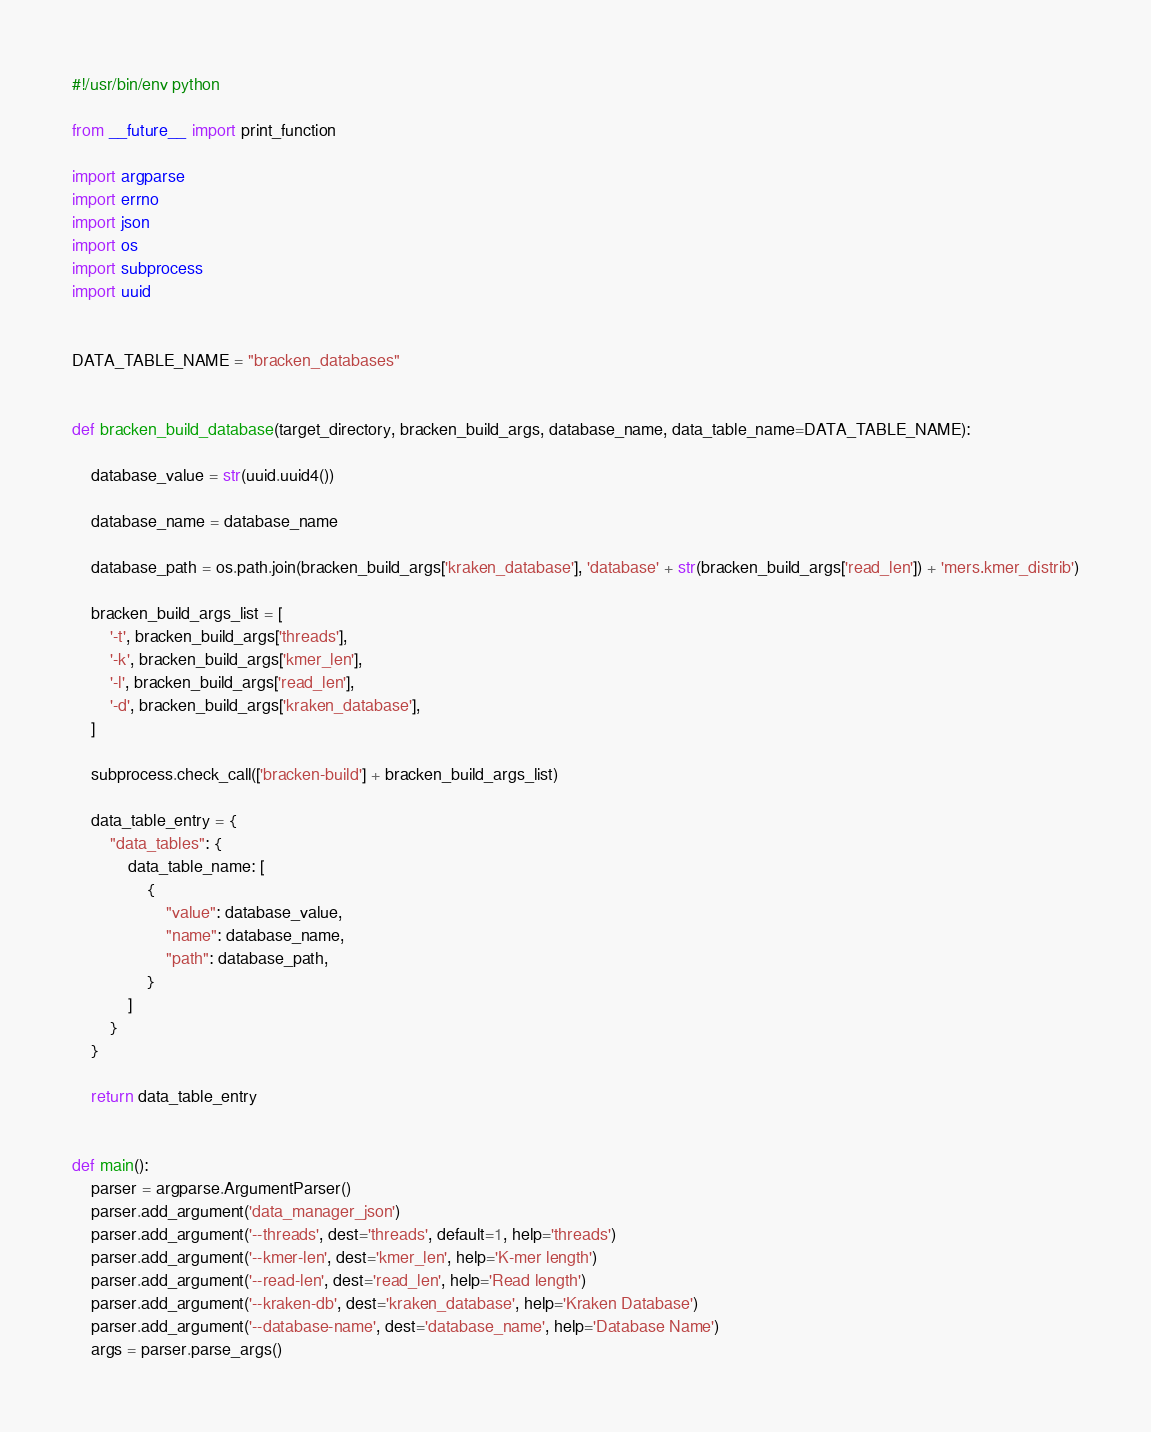Convert code to text. <code><loc_0><loc_0><loc_500><loc_500><_Python_>#!/usr/bin/env python

from __future__ import print_function

import argparse
import errno
import json
import os
import subprocess
import uuid


DATA_TABLE_NAME = "bracken_databases"


def bracken_build_database(target_directory, bracken_build_args, database_name, data_table_name=DATA_TABLE_NAME):

    database_value = str(uuid.uuid4())

    database_name = database_name

    database_path = os.path.join(bracken_build_args['kraken_database'], 'database' + str(bracken_build_args['read_len']) + 'mers.kmer_distrib')

    bracken_build_args_list = [
        '-t', bracken_build_args['threads'],
        '-k', bracken_build_args['kmer_len'],
        '-l', bracken_build_args['read_len'],
        '-d', bracken_build_args['kraken_database'],
    ]

    subprocess.check_call(['bracken-build'] + bracken_build_args_list)

    data_table_entry = {
        "data_tables": {
            data_table_name: [
                {
                    "value": database_value,
                    "name": database_name,
                    "path": database_path,
                }
            ]
        }
    }

    return data_table_entry


def main():
    parser = argparse.ArgumentParser()
    parser.add_argument('data_manager_json')
    parser.add_argument('--threads', dest='threads', default=1, help='threads')
    parser.add_argument('--kmer-len', dest='kmer_len', help='K-mer length')
    parser.add_argument('--read-len', dest='read_len', help='Read length')
    parser.add_argument('--kraken-db', dest='kraken_database', help='Kraken Database')
    parser.add_argument('--database-name', dest='database_name', help='Database Name')
    args = parser.parse_args()
</code> 